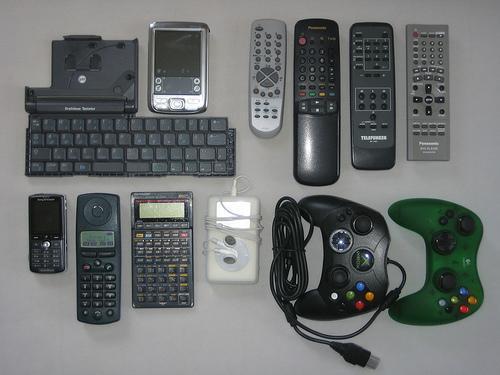How many game remotes are pictured?
Give a very brief answer. 2. How many video game controllers are in the picture?
Give a very brief answer. 2. How many remotes are there?
Give a very brief answer. 4. How many are silver?
Give a very brief answer. 3. How many remotes are in the photo?
Give a very brief answer. 7. How many keyboards are in the photo?
Give a very brief answer. 1. How many cell phones are in the photo?
Give a very brief answer. 3. How many slices of pizza have broccoli?
Give a very brief answer. 0. 